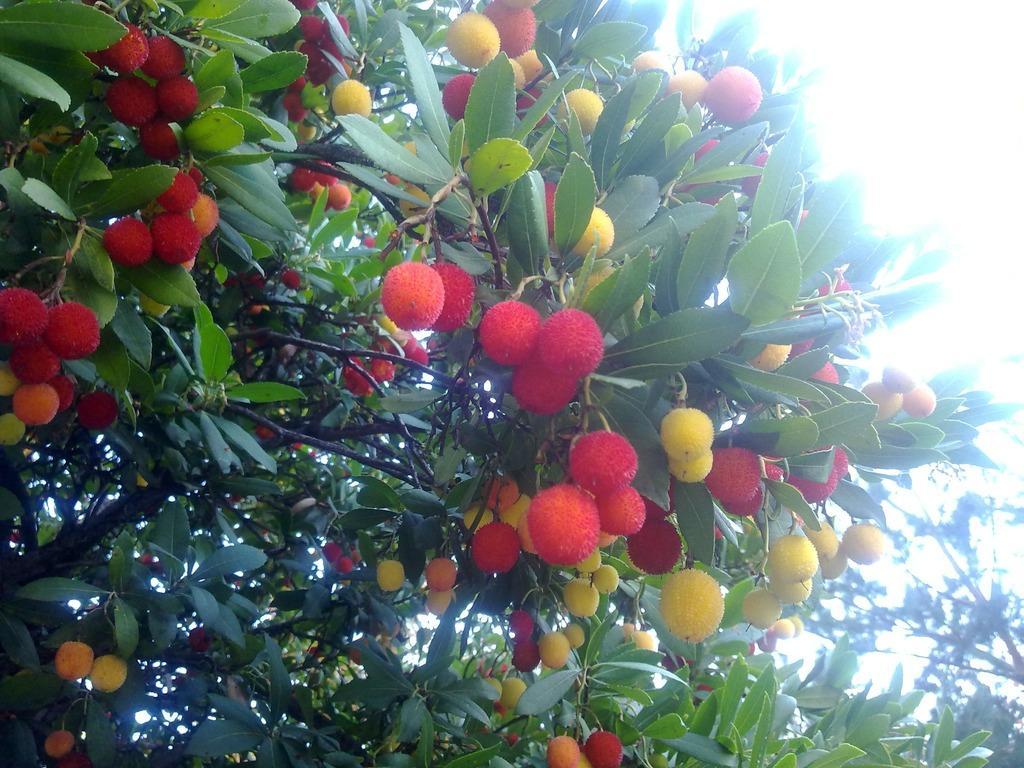Could you give a brief overview of what you see in this image? In this image we can see some trees with so many fruits. 